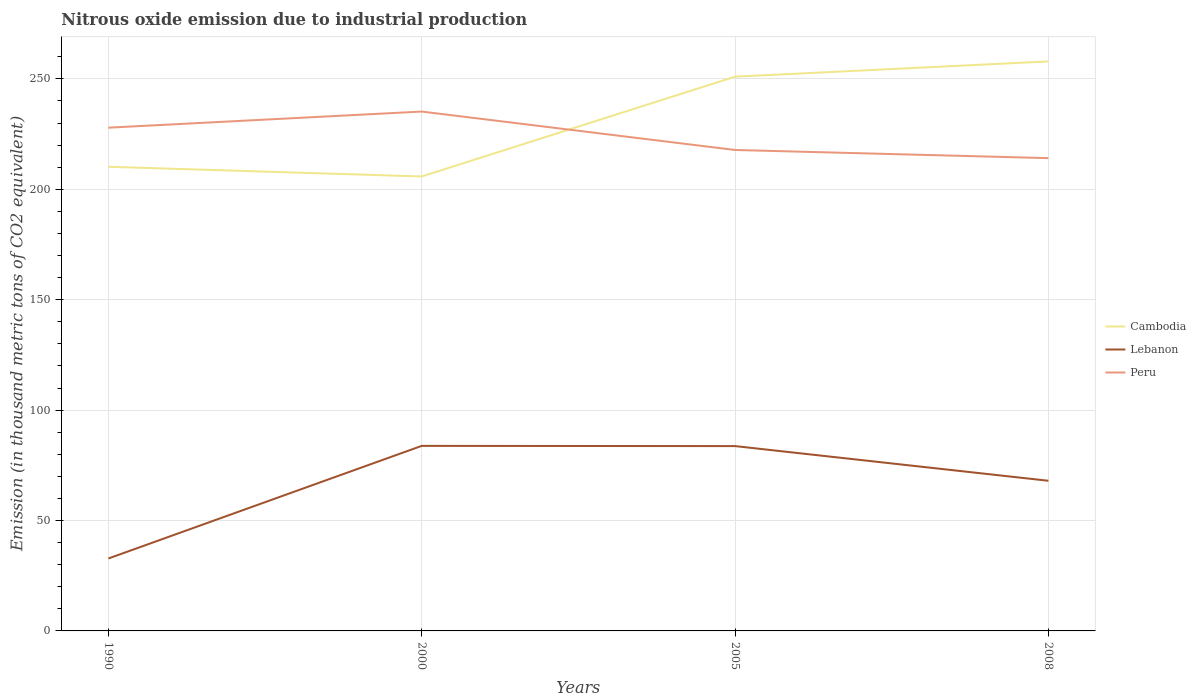How many different coloured lines are there?
Your answer should be compact. 3. Does the line corresponding to Cambodia intersect with the line corresponding to Lebanon?
Offer a terse response. No. Is the number of lines equal to the number of legend labels?
Your answer should be very brief. Yes. Across all years, what is the maximum amount of nitrous oxide emitted in Peru?
Offer a terse response. 214.1. In which year was the amount of nitrous oxide emitted in Peru maximum?
Your answer should be very brief. 2008. What is the total amount of nitrous oxide emitted in Cambodia in the graph?
Ensure brevity in your answer.  -45.2. What is the difference between the highest and the second highest amount of nitrous oxide emitted in Cambodia?
Provide a succinct answer. 52.1. What is the difference between the highest and the lowest amount of nitrous oxide emitted in Lebanon?
Give a very brief answer. 3. Is the amount of nitrous oxide emitted in Peru strictly greater than the amount of nitrous oxide emitted in Lebanon over the years?
Your answer should be very brief. No. How many years are there in the graph?
Your answer should be compact. 4. What is the difference between two consecutive major ticks on the Y-axis?
Your answer should be compact. 50. How many legend labels are there?
Make the answer very short. 3. How are the legend labels stacked?
Keep it short and to the point. Vertical. What is the title of the graph?
Offer a terse response. Nitrous oxide emission due to industrial production. Does "Malawi" appear as one of the legend labels in the graph?
Ensure brevity in your answer.  No. What is the label or title of the X-axis?
Provide a succinct answer. Years. What is the label or title of the Y-axis?
Provide a short and direct response. Emission (in thousand metric tons of CO2 equivalent). What is the Emission (in thousand metric tons of CO2 equivalent) in Cambodia in 1990?
Ensure brevity in your answer.  210.2. What is the Emission (in thousand metric tons of CO2 equivalent) in Lebanon in 1990?
Your answer should be very brief. 32.8. What is the Emission (in thousand metric tons of CO2 equivalent) in Peru in 1990?
Provide a succinct answer. 227.9. What is the Emission (in thousand metric tons of CO2 equivalent) in Cambodia in 2000?
Keep it short and to the point. 205.8. What is the Emission (in thousand metric tons of CO2 equivalent) of Lebanon in 2000?
Make the answer very short. 83.8. What is the Emission (in thousand metric tons of CO2 equivalent) of Peru in 2000?
Keep it short and to the point. 235.2. What is the Emission (in thousand metric tons of CO2 equivalent) of Cambodia in 2005?
Your answer should be compact. 251. What is the Emission (in thousand metric tons of CO2 equivalent) in Lebanon in 2005?
Your response must be concise. 83.7. What is the Emission (in thousand metric tons of CO2 equivalent) in Peru in 2005?
Give a very brief answer. 217.8. What is the Emission (in thousand metric tons of CO2 equivalent) in Cambodia in 2008?
Your answer should be compact. 257.9. What is the Emission (in thousand metric tons of CO2 equivalent) in Peru in 2008?
Give a very brief answer. 214.1. Across all years, what is the maximum Emission (in thousand metric tons of CO2 equivalent) of Cambodia?
Your response must be concise. 257.9. Across all years, what is the maximum Emission (in thousand metric tons of CO2 equivalent) in Lebanon?
Make the answer very short. 83.8. Across all years, what is the maximum Emission (in thousand metric tons of CO2 equivalent) in Peru?
Your response must be concise. 235.2. Across all years, what is the minimum Emission (in thousand metric tons of CO2 equivalent) of Cambodia?
Provide a succinct answer. 205.8. Across all years, what is the minimum Emission (in thousand metric tons of CO2 equivalent) in Lebanon?
Make the answer very short. 32.8. Across all years, what is the minimum Emission (in thousand metric tons of CO2 equivalent) in Peru?
Your response must be concise. 214.1. What is the total Emission (in thousand metric tons of CO2 equivalent) in Cambodia in the graph?
Your answer should be very brief. 924.9. What is the total Emission (in thousand metric tons of CO2 equivalent) of Lebanon in the graph?
Make the answer very short. 268.3. What is the total Emission (in thousand metric tons of CO2 equivalent) of Peru in the graph?
Provide a succinct answer. 895. What is the difference between the Emission (in thousand metric tons of CO2 equivalent) of Lebanon in 1990 and that in 2000?
Your answer should be compact. -51. What is the difference between the Emission (in thousand metric tons of CO2 equivalent) of Cambodia in 1990 and that in 2005?
Your answer should be very brief. -40.8. What is the difference between the Emission (in thousand metric tons of CO2 equivalent) in Lebanon in 1990 and that in 2005?
Keep it short and to the point. -50.9. What is the difference between the Emission (in thousand metric tons of CO2 equivalent) in Peru in 1990 and that in 2005?
Your answer should be compact. 10.1. What is the difference between the Emission (in thousand metric tons of CO2 equivalent) of Cambodia in 1990 and that in 2008?
Your answer should be very brief. -47.7. What is the difference between the Emission (in thousand metric tons of CO2 equivalent) of Lebanon in 1990 and that in 2008?
Provide a succinct answer. -35.2. What is the difference between the Emission (in thousand metric tons of CO2 equivalent) of Peru in 1990 and that in 2008?
Make the answer very short. 13.8. What is the difference between the Emission (in thousand metric tons of CO2 equivalent) of Cambodia in 2000 and that in 2005?
Provide a succinct answer. -45.2. What is the difference between the Emission (in thousand metric tons of CO2 equivalent) of Lebanon in 2000 and that in 2005?
Make the answer very short. 0.1. What is the difference between the Emission (in thousand metric tons of CO2 equivalent) of Peru in 2000 and that in 2005?
Keep it short and to the point. 17.4. What is the difference between the Emission (in thousand metric tons of CO2 equivalent) of Cambodia in 2000 and that in 2008?
Offer a terse response. -52.1. What is the difference between the Emission (in thousand metric tons of CO2 equivalent) in Lebanon in 2000 and that in 2008?
Keep it short and to the point. 15.8. What is the difference between the Emission (in thousand metric tons of CO2 equivalent) in Peru in 2000 and that in 2008?
Your answer should be very brief. 21.1. What is the difference between the Emission (in thousand metric tons of CO2 equivalent) of Peru in 2005 and that in 2008?
Offer a terse response. 3.7. What is the difference between the Emission (in thousand metric tons of CO2 equivalent) of Cambodia in 1990 and the Emission (in thousand metric tons of CO2 equivalent) of Lebanon in 2000?
Offer a terse response. 126.4. What is the difference between the Emission (in thousand metric tons of CO2 equivalent) in Lebanon in 1990 and the Emission (in thousand metric tons of CO2 equivalent) in Peru in 2000?
Ensure brevity in your answer.  -202.4. What is the difference between the Emission (in thousand metric tons of CO2 equivalent) in Cambodia in 1990 and the Emission (in thousand metric tons of CO2 equivalent) in Lebanon in 2005?
Your answer should be compact. 126.5. What is the difference between the Emission (in thousand metric tons of CO2 equivalent) in Lebanon in 1990 and the Emission (in thousand metric tons of CO2 equivalent) in Peru in 2005?
Provide a short and direct response. -185. What is the difference between the Emission (in thousand metric tons of CO2 equivalent) in Cambodia in 1990 and the Emission (in thousand metric tons of CO2 equivalent) in Lebanon in 2008?
Keep it short and to the point. 142.2. What is the difference between the Emission (in thousand metric tons of CO2 equivalent) of Cambodia in 1990 and the Emission (in thousand metric tons of CO2 equivalent) of Peru in 2008?
Offer a very short reply. -3.9. What is the difference between the Emission (in thousand metric tons of CO2 equivalent) in Lebanon in 1990 and the Emission (in thousand metric tons of CO2 equivalent) in Peru in 2008?
Your response must be concise. -181.3. What is the difference between the Emission (in thousand metric tons of CO2 equivalent) of Cambodia in 2000 and the Emission (in thousand metric tons of CO2 equivalent) of Lebanon in 2005?
Your answer should be compact. 122.1. What is the difference between the Emission (in thousand metric tons of CO2 equivalent) in Cambodia in 2000 and the Emission (in thousand metric tons of CO2 equivalent) in Peru in 2005?
Keep it short and to the point. -12. What is the difference between the Emission (in thousand metric tons of CO2 equivalent) in Lebanon in 2000 and the Emission (in thousand metric tons of CO2 equivalent) in Peru in 2005?
Make the answer very short. -134. What is the difference between the Emission (in thousand metric tons of CO2 equivalent) in Cambodia in 2000 and the Emission (in thousand metric tons of CO2 equivalent) in Lebanon in 2008?
Offer a terse response. 137.8. What is the difference between the Emission (in thousand metric tons of CO2 equivalent) of Cambodia in 2000 and the Emission (in thousand metric tons of CO2 equivalent) of Peru in 2008?
Your answer should be very brief. -8.3. What is the difference between the Emission (in thousand metric tons of CO2 equivalent) in Lebanon in 2000 and the Emission (in thousand metric tons of CO2 equivalent) in Peru in 2008?
Provide a succinct answer. -130.3. What is the difference between the Emission (in thousand metric tons of CO2 equivalent) of Cambodia in 2005 and the Emission (in thousand metric tons of CO2 equivalent) of Lebanon in 2008?
Make the answer very short. 183. What is the difference between the Emission (in thousand metric tons of CO2 equivalent) in Cambodia in 2005 and the Emission (in thousand metric tons of CO2 equivalent) in Peru in 2008?
Your response must be concise. 36.9. What is the difference between the Emission (in thousand metric tons of CO2 equivalent) of Lebanon in 2005 and the Emission (in thousand metric tons of CO2 equivalent) of Peru in 2008?
Your response must be concise. -130.4. What is the average Emission (in thousand metric tons of CO2 equivalent) of Cambodia per year?
Your answer should be very brief. 231.22. What is the average Emission (in thousand metric tons of CO2 equivalent) in Lebanon per year?
Offer a terse response. 67.08. What is the average Emission (in thousand metric tons of CO2 equivalent) in Peru per year?
Your answer should be very brief. 223.75. In the year 1990, what is the difference between the Emission (in thousand metric tons of CO2 equivalent) of Cambodia and Emission (in thousand metric tons of CO2 equivalent) of Lebanon?
Your answer should be compact. 177.4. In the year 1990, what is the difference between the Emission (in thousand metric tons of CO2 equivalent) of Cambodia and Emission (in thousand metric tons of CO2 equivalent) of Peru?
Keep it short and to the point. -17.7. In the year 1990, what is the difference between the Emission (in thousand metric tons of CO2 equivalent) in Lebanon and Emission (in thousand metric tons of CO2 equivalent) in Peru?
Provide a short and direct response. -195.1. In the year 2000, what is the difference between the Emission (in thousand metric tons of CO2 equivalent) of Cambodia and Emission (in thousand metric tons of CO2 equivalent) of Lebanon?
Offer a terse response. 122. In the year 2000, what is the difference between the Emission (in thousand metric tons of CO2 equivalent) of Cambodia and Emission (in thousand metric tons of CO2 equivalent) of Peru?
Offer a very short reply. -29.4. In the year 2000, what is the difference between the Emission (in thousand metric tons of CO2 equivalent) of Lebanon and Emission (in thousand metric tons of CO2 equivalent) of Peru?
Ensure brevity in your answer.  -151.4. In the year 2005, what is the difference between the Emission (in thousand metric tons of CO2 equivalent) in Cambodia and Emission (in thousand metric tons of CO2 equivalent) in Lebanon?
Make the answer very short. 167.3. In the year 2005, what is the difference between the Emission (in thousand metric tons of CO2 equivalent) in Cambodia and Emission (in thousand metric tons of CO2 equivalent) in Peru?
Ensure brevity in your answer.  33.2. In the year 2005, what is the difference between the Emission (in thousand metric tons of CO2 equivalent) of Lebanon and Emission (in thousand metric tons of CO2 equivalent) of Peru?
Give a very brief answer. -134.1. In the year 2008, what is the difference between the Emission (in thousand metric tons of CO2 equivalent) in Cambodia and Emission (in thousand metric tons of CO2 equivalent) in Lebanon?
Give a very brief answer. 189.9. In the year 2008, what is the difference between the Emission (in thousand metric tons of CO2 equivalent) in Cambodia and Emission (in thousand metric tons of CO2 equivalent) in Peru?
Provide a succinct answer. 43.8. In the year 2008, what is the difference between the Emission (in thousand metric tons of CO2 equivalent) of Lebanon and Emission (in thousand metric tons of CO2 equivalent) of Peru?
Your answer should be very brief. -146.1. What is the ratio of the Emission (in thousand metric tons of CO2 equivalent) of Cambodia in 1990 to that in 2000?
Offer a terse response. 1.02. What is the ratio of the Emission (in thousand metric tons of CO2 equivalent) in Lebanon in 1990 to that in 2000?
Provide a succinct answer. 0.39. What is the ratio of the Emission (in thousand metric tons of CO2 equivalent) in Peru in 1990 to that in 2000?
Offer a very short reply. 0.97. What is the ratio of the Emission (in thousand metric tons of CO2 equivalent) of Cambodia in 1990 to that in 2005?
Your response must be concise. 0.84. What is the ratio of the Emission (in thousand metric tons of CO2 equivalent) in Lebanon in 1990 to that in 2005?
Give a very brief answer. 0.39. What is the ratio of the Emission (in thousand metric tons of CO2 equivalent) of Peru in 1990 to that in 2005?
Ensure brevity in your answer.  1.05. What is the ratio of the Emission (in thousand metric tons of CO2 equivalent) of Cambodia in 1990 to that in 2008?
Your answer should be very brief. 0.81. What is the ratio of the Emission (in thousand metric tons of CO2 equivalent) of Lebanon in 1990 to that in 2008?
Make the answer very short. 0.48. What is the ratio of the Emission (in thousand metric tons of CO2 equivalent) in Peru in 1990 to that in 2008?
Give a very brief answer. 1.06. What is the ratio of the Emission (in thousand metric tons of CO2 equivalent) in Cambodia in 2000 to that in 2005?
Provide a succinct answer. 0.82. What is the ratio of the Emission (in thousand metric tons of CO2 equivalent) in Lebanon in 2000 to that in 2005?
Ensure brevity in your answer.  1. What is the ratio of the Emission (in thousand metric tons of CO2 equivalent) of Peru in 2000 to that in 2005?
Make the answer very short. 1.08. What is the ratio of the Emission (in thousand metric tons of CO2 equivalent) of Cambodia in 2000 to that in 2008?
Keep it short and to the point. 0.8. What is the ratio of the Emission (in thousand metric tons of CO2 equivalent) of Lebanon in 2000 to that in 2008?
Your answer should be very brief. 1.23. What is the ratio of the Emission (in thousand metric tons of CO2 equivalent) in Peru in 2000 to that in 2008?
Your answer should be very brief. 1.1. What is the ratio of the Emission (in thousand metric tons of CO2 equivalent) of Cambodia in 2005 to that in 2008?
Make the answer very short. 0.97. What is the ratio of the Emission (in thousand metric tons of CO2 equivalent) in Lebanon in 2005 to that in 2008?
Provide a short and direct response. 1.23. What is the ratio of the Emission (in thousand metric tons of CO2 equivalent) of Peru in 2005 to that in 2008?
Provide a succinct answer. 1.02. What is the difference between the highest and the second highest Emission (in thousand metric tons of CO2 equivalent) of Cambodia?
Keep it short and to the point. 6.9. What is the difference between the highest and the second highest Emission (in thousand metric tons of CO2 equivalent) in Lebanon?
Provide a short and direct response. 0.1. What is the difference between the highest and the lowest Emission (in thousand metric tons of CO2 equivalent) of Cambodia?
Your response must be concise. 52.1. What is the difference between the highest and the lowest Emission (in thousand metric tons of CO2 equivalent) of Lebanon?
Ensure brevity in your answer.  51. What is the difference between the highest and the lowest Emission (in thousand metric tons of CO2 equivalent) in Peru?
Your answer should be compact. 21.1. 